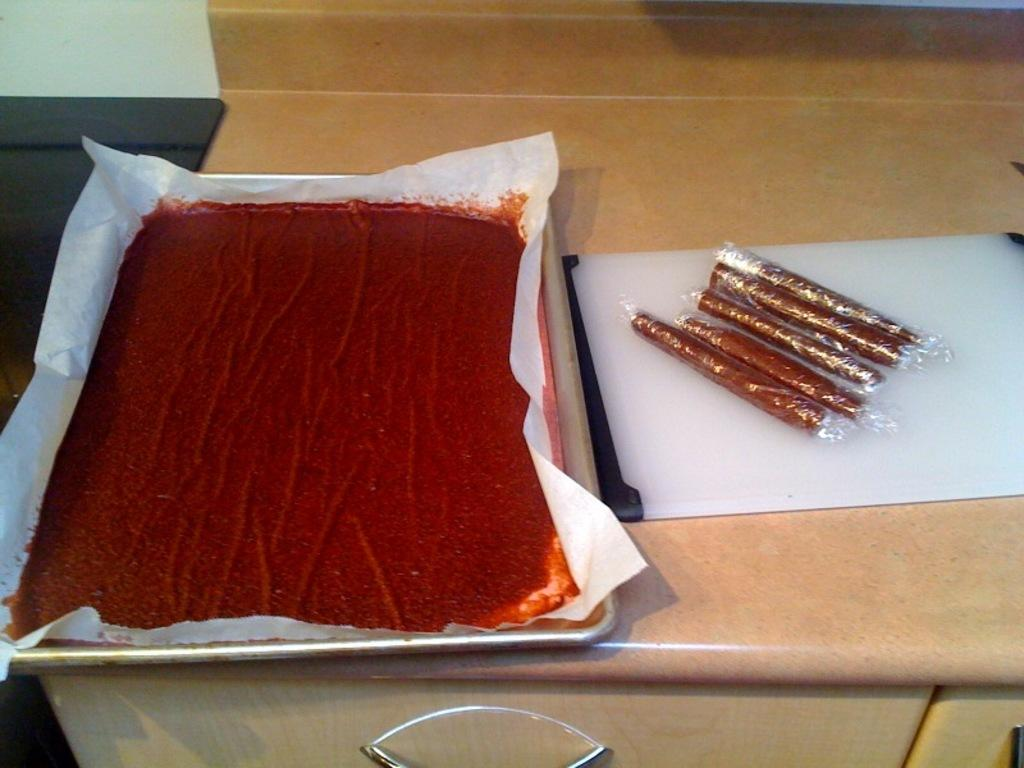What color is the food item that is visible in the image? There is a red-colored food item in the image. How are the red-colored food items arranged in the image? The red-colored food item is kept in a tray. What type of food items are made into rolls in the image? The food items made into rolls are also kept in a tray. What is the primary piece of furniture in the image? There is a table in the image. What decision does the ghost make about the food items in the image? There is no ghost present in the image, so no decision can be made by a ghost about the food items. 